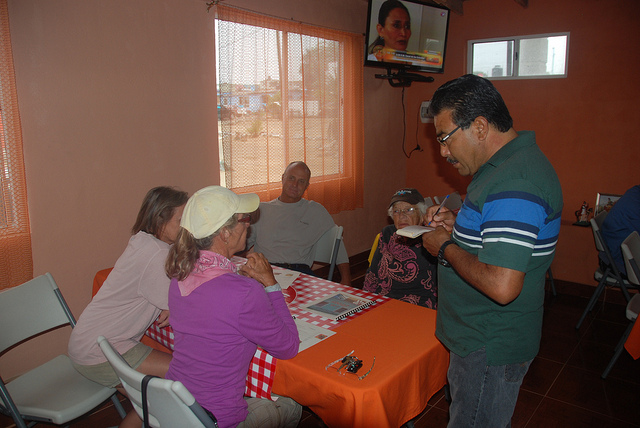<image>Where is the equal sign? There is no equal sign in the image. However, it can be on the notebook, tablet, or paper. Is everyone getting the daily special? It is unknown if everyone is getting the daily special. Where is the equal sign? I am not sure where the equal sign is. It can be seen on the tablet, notebook, or paper. Is everyone getting the daily special? I don't know if everyone is getting the daily special. Some may be getting it, while others may not. 